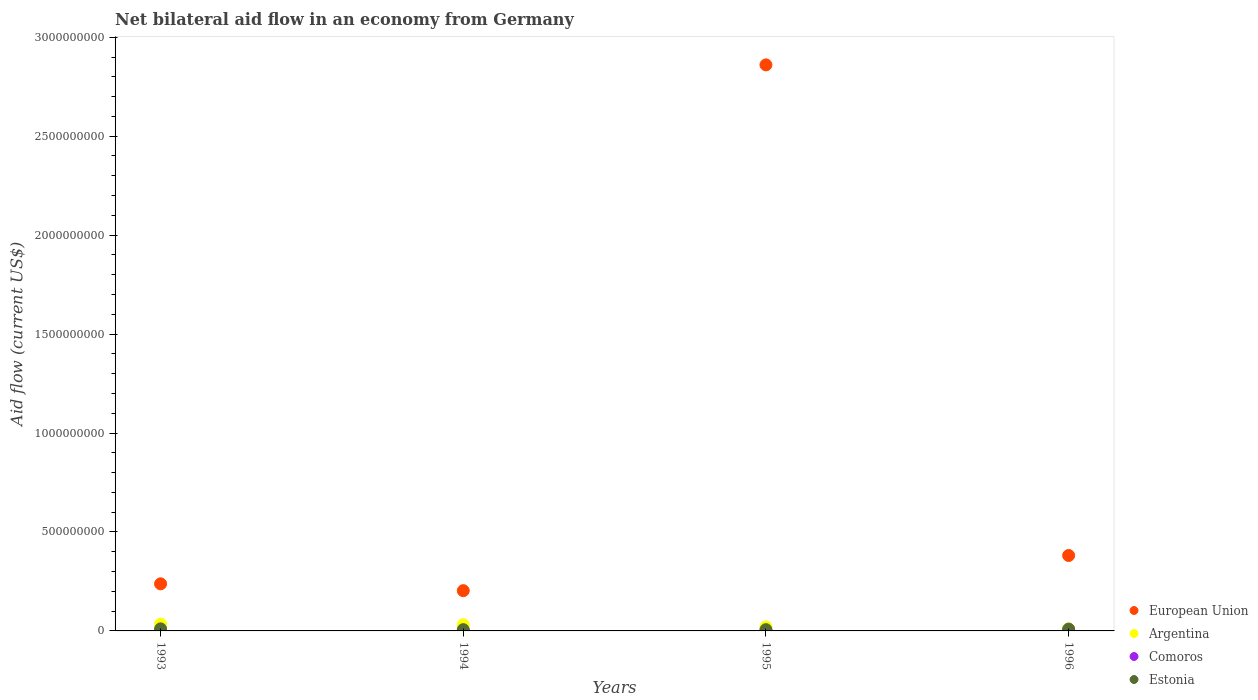What is the net bilateral aid flow in Estonia in 1995?
Provide a short and direct response. 6.40e+06. Across all years, what is the maximum net bilateral aid flow in European Union?
Provide a short and direct response. 2.86e+09. Across all years, what is the minimum net bilateral aid flow in European Union?
Provide a succinct answer. 2.03e+08. In which year was the net bilateral aid flow in Comoros minimum?
Your answer should be very brief. 1995. What is the total net bilateral aid flow in Argentina in the graph?
Keep it short and to the point. 9.65e+07. What is the difference between the net bilateral aid flow in Argentina in 1995 and that in 1996?
Keep it short and to the point. 1.02e+07. What is the difference between the net bilateral aid flow in Argentina in 1994 and the net bilateral aid flow in Estonia in 1996?
Keep it short and to the point. 2.22e+07. What is the average net bilateral aid flow in Estonia per year?
Provide a succinct answer. 8.15e+06. In the year 1994, what is the difference between the net bilateral aid flow in Argentina and net bilateral aid flow in Estonia?
Provide a short and direct response. 2.52e+07. What is the ratio of the net bilateral aid flow in Argentina in 1994 to that in 1995?
Provide a short and direct response. 1.54. Is the net bilateral aid flow in European Union in 1994 less than that in 1996?
Ensure brevity in your answer.  Yes. What is the difference between the highest and the second highest net bilateral aid flow in Estonia?
Make the answer very short. 1.11e+06. What is the difference between the highest and the lowest net bilateral aid flow in Estonia?
Your answer should be very brief. 4.08e+06. How many dotlines are there?
Your answer should be compact. 4. What is the difference between two consecutive major ticks on the Y-axis?
Give a very brief answer. 5.00e+08. Are the values on the major ticks of Y-axis written in scientific E-notation?
Offer a very short reply. No. Where does the legend appear in the graph?
Ensure brevity in your answer.  Bottom right. How many legend labels are there?
Offer a very short reply. 4. How are the legend labels stacked?
Offer a terse response. Vertical. What is the title of the graph?
Your answer should be very brief. Net bilateral aid flow in an economy from Germany. What is the label or title of the X-axis?
Ensure brevity in your answer.  Years. What is the label or title of the Y-axis?
Offer a terse response. Aid flow (current US$). What is the Aid flow (current US$) of European Union in 1993?
Offer a very short reply. 2.38e+08. What is the Aid flow (current US$) in Argentina in 1993?
Your answer should be compact. 3.42e+07. What is the Aid flow (current US$) of Comoros in 1993?
Keep it short and to the point. 1.64e+06. What is the Aid flow (current US$) of Estonia in 1993?
Offer a terse response. 1.05e+07. What is the Aid flow (current US$) of European Union in 1994?
Provide a short and direct response. 2.03e+08. What is the Aid flow (current US$) of Argentina in 1994?
Your answer should be very brief. 3.15e+07. What is the Aid flow (current US$) in Comoros in 1994?
Offer a terse response. 3.90e+05. What is the Aid flow (current US$) in Estonia in 1994?
Keep it short and to the point. 6.38e+06. What is the Aid flow (current US$) of European Union in 1995?
Provide a short and direct response. 2.86e+09. What is the Aid flow (current US$) of Argentina in 1995?
Provide a succinct answer. 2.05e+07. What is the Aid flow (current US$) of Estonia in 1995?
Your answer should be very brief. 6.40e+06. What is the Aid flow (current US$) of European Union in 1996?
Offer a very short reply. 3.81e+08. What is the Aid flow (current US$) in Argentina in 1996?
Offer a terse response. 1.03e+07. What is the Aid flow (current US$) in Comoros in 1996?
Your response must be concise. 9.50e+05. What is the Aid flow (current US$) in Estonia in 1996?
Offer a very short reply. 9.35e+06. Across all years, what is the maximum Aid flow (current US$) of European Union?
Offer a very short reply. 2.86e+09. Across all years, what is the maximum Aid flow (current US$) in Argentina?
Ensure brevity in your answer.  3.42e+07. Across all years, what is the maximum Aid flow (current US$) of Comoros?
Make the answer very short. 1.64e+06. Across all years, what is the maximum Aid flow (current US$) in Estonia?
Ensure brevity in your answer.  1.05e+07. Across all years, what is the minimum Aid flow (current US$) of European Union?
Give a very brief answer. 2.03e+08. Across all years, what is the minimum Aid flow (current US$) in Argentina?
Your response must be concise. 1.03e+07. Across all years, what is the minimum Aid flow (current US$) in Comoros?
Make the answer very short. 2.10e+05. Across all years, what is the minimum Aid flow (current US$) in Estonia?
Your answer should be compact. 6.38e+06. What is the total Aid flow (current US$) of European Union in the graph?
Offer a very short reply. 3.68e+09. What is the total Aid flow (current US$) of Argentina in the graph?
Keep it short and to the point. 9.65e+07. What is the total Aid flow (current US$) of Comoros in the graph?
Make the answer very short. 3.19e+06. What is the total Aid flow (current US$) of Estonia in the graph?
Your answer should be compact. 3.26e+07. What is the difference between the Aid flow (current US$) in European Union in 1993 and that in 1994?
Give a very brief answer. 3.46e+07. What is the difference between the Aid flow (current US$) in Argentina in 1993 and that in 1994?
Offer a terse response. 2.62e+06. What is the difference between the Aid flow (current US$) in Comoros in 1993 and that in 1994?
Offer a very short reply. 1.25e+06. What is the difference between the Aid flow (current US$) of Estonia in 1993 and that in 1994?
Ensure brevity in your answer.  4.08e+06. What is the difference between the Aid flow (current US$) in European Union in 1993 and that in 1995?
Make the answer very short. -2.62e+09. What is the difference between the Aid flow (current US$) of Argentina in 1993 and that in 1995?
Make the answer very short. 1.37e+07. What is the difference between the Aid flow (current US$) in Comoros in 1993 and that in 1995?
Offer a very short reply. 1.43e+06. What is the difference between the Aid flow (current US$) in Estonia in 1993 and that in 1995?
Provide a short and direct response. 4.06e+06. What is the difference between the Aid flow (current US$) in European Union in 1993 and that in 1996?
Provide a short and direct response. -1.43e+08. What is the difference between the Aid flow (current US$) in Argentina in 1993 and that in 1996?
Keep it short and to the point. 2.39e+07. What is the difference between the Aid flow (current US$) in Comoros in 1993 and that in 1996?
Provide a succinct answer. 6.90e+05. What is the difference between the Aid flow (current US$) in Estonia in 1993 and that in 1996?
Your answer should be very brief. 1.11e+06. What is the difference between the Aid flow (current US$) of European Union in 1994 and that in 1995?
Give a very brief answer. -2.66e+09. What is the difference between the Aid flow (current US$) of Argentina in 1994 and that in 1995?
Give a very brief answer. 1.11e+07. What is the difference between the Aid flow (current US$) of Estonia in 1994 and that in 1995?
Ensure brevity in your answer.  -2.00e+04. What is the difference between the Aid flow (current US$) in European Union in 1994 and that in 1996?
Provide a succinct answer. -1.78e+08. What is the difference between the Aid flow (current US$) in Argentina in 1994 and that in 1996?
Keep it short and to the point. 2.12e+07. What is the difference between the Aid flow (current US$) in Comoros in 1994 and that in 1996?
Your answer should be very brief. -5.60e+05. What is the difference between the Aid flow (current US$) in Estonia in 1994 and that in 1996?
Offer a terse response. -2.97e+06. What is the difference between the Aid flow (current US$) in European Union in 1995 and that in 1996?
Provide a succinct answer. 2.48e+09. What is the difference between the Aid flow (current US$) in Argentina in 1995 and that in 1996?
Provide a short and direct response. 1.02e+07. What is the difference between the Aid flow (current US$) in Comoros in 1995 and that in 1996?
Your answer should be compact. -7.40e+05. What is the difference between the Aid flow (current US$) of Estonia in 1995 and that in 1996?
Your response must be concise. -2.95e+06. What is the difference between the Aid flow (current US$) in European Union in 1993 and the Aid flow (current US$) in Argentina in 1994?
Your answer should be very brief. 2.06e+08. What is the difference between the Aid flow (current US$) in European Union in 1993 and the Aid flow (current US$) in Comoros in 1994?
Your response must be concise. 2.38e+08. What is the difference between the Aid flow (current US$) of European Union in 1993 and the Aid flow (current US$) of Estonia in 1994?
Your answer should be compact. 2.32e+08. What is the difference between the Aid flow (current US$) of Argentina in 1993 and the Aid flow (current US$) of Comoros in 1994?
Offer a terse response. 3.38e+07. What is the difference between the Aid flow (current US$) in Argentina in 1993 and the Aid flow (current US$) in Estonia in 1994?
Provide a short and direct response. 2.78e+07. What is the difference between the Aid flow (current US$) in Comoros in 1993 and the Aid flow (current US$) in Estonia in 1994?
Provide a short and direct response. -4.74e+06. What is the difference between the Aid flow (current US$) in European Union in 1993 and the Aid flow (current US$) in Argentina in 1995?
Make the answer very short. 2.18e+08. What is the difference between the Aid flow (current US$) of European Union in 1993 and the Aid flow (current US$) of Comoros in 1995?
Make the answer very short. 2.38e+08. What is the difference between the Aid flow (current US$) of European Union in 1993 and the Aid flow (current US$) of Estonia in 1995?
Your answer should be very brief. 2.32e+08. What is the difference between the Aid flow (current US$) in Argentina in 1993 and the Aid flow (current US$) in Comoros in 1995?
Your response must be concise. 3.40e+07. What is the difference between the Aid flow (current US$) in Argentina in 1993 and the Aid flow (current US$) in Estonia in 1995?
Your response must be concise. 2.78e+07. What is the difference between the Aid flow (current US$) in Comoros in 1993 and the Aid flow (current US$) in Estonia in 1995?
Make the answer very short. -4.76e+06. What is the difference between the Aid flow (current US$) in European Union in 1993 and the Aid flow (current US$) in Argentina in 1996?
Your response must be concise. 2.28e+08. What is the difference between the Aid flow (current US$) in European Union in 1993 and the Aid flow (current US$) in Comoros in 1996?
Make the answer very short. 2.37e+08. What is the difference between the Aid flow (current US$) of European Union in 1993 and the Aid flow (current US$) of Estonia in 1996?
Provide a short and direct response. 2.29e+08. What is the difference between the Aid flow (current US$) of Argentina in 1993 and the Aid flow (current US$) of Comoros in 1996?
Give a very brief answer. 3.32e+07. What is the difference between the Aid flow (current US$) in Argentina in 1993 and the Aid flow (current US$) in Estonia in 1996?
Your answer should be very brief. 2.48e+07. What is the difference between the Aid flow (current US$) in Comoros in 1993 and the Aid flow (current US$) in Estonia in 1996?
Ensure brevity in your answer.  -7.71e+06. What is the difference between the Aid flow (current US$) of European Union in 1994 and the Aid flow (current US$) of Argentina in 1995?
Your response must be concise. 1.83e+08. What is the difference between the Aid flow (current US$) of European Union in 1994 and the Aid flow (current US$) of Comoros in 1995?
Ensure brevity in your answer.  2.03e+08. What is the difference between the Aid flow (current US$) in European Union in 1994 and the Aid flow (current US$) in Estonia in 1995?
Offer a terse response. 1.97e+08. What is the difference between the Aid flow (current US$) in Argentina in 1994 and the Aid flow (current US$) in Comoros in 1995?
Offer a terse response. 3.13e+07. What is the difference between the Aid flow (current US$) of Argentina in 1994 and the Aid flow (current US$) of Estonia in 1995?
Your response must be concise. 2.51e+07. What is the difference between the Aid flow (current US$) of Comoros in 1994 and the Aid flow (current US$) of Estonia in 1995?
Make the answer very short. -6.01e+06. What is the difference between the Aid flow (current US$) of European Union in 1994 and the Aid flow (current US$) of Argentina in 1996?
Provide a succinct answer. 1.93e+08. What is the difference between the Aid flow (current US$) of European Union in 1994 and the Aid flow (current US$) of Comoros in 1996?
Provide a succinct answer. 2.02e+08. What is the difference between the Aid flow (current US$) in European Union in 1994 and the Aid flow (current US$) in Estonia in 1996?
Give a very brief answer. 1.94e+08. What is the difference between the Aid flow (current US$) of Argentina in 1994 and the Aid flow (current US$) of Comoros in 1996?
Give a very brief answer. 3.06e+07. What is the difference between the Aid flow (current US$) of Argentina in 1994 and the Aid flow (current US$) of Estonia in 1996?
Keep it short and to the point. 2.22e+07. What is the difference between the Aid flow (current US$) in Comoros in 1994 and the Aid flow (current US$) in Estonia in 1996?
Ensure brevity in your answer.  -8.96e+06. What is the difference between the Aid flow (current US$) in European Union in 1995 and the Aid flow (current US$) in Argentina in 1996?
Your answer should be compact. 2.85e+09. What is the difference between the Aid flow (current US$) in European Union in 1995 and the Aid flow (current US$) in Comoros in 1996?
Your response must be concise. 2.86e+09. What is the difference between the Aid flow (current US$) of European Union in 1995 and the Aid flow (current US$) of Estonia in 1996?
Give a very brief answer. 2.85e+09. What is the difference between the Aid flow (current US$) of Argentina in 1995 and the Aid flow (current US$) of Comoros in 1996?
Give a very brief answer. 1.95e+07. What is the difference between the Aid flow (current US$) in Argentina in 1995 and the Aid flow (current US$) in Estonia in 1996?
Make the answer very short. 1.11e+07. What is the difference between the Aid flow (current US$) in Comoros in 1995 and the Aid flow (current US$) in Estonia in 1996?
Offer a very short reply. -9.14e+06. What is the average Aid flow (current US$) in European Union per year?
Provide a short and direct response. 9.21e+08. What is the average Aid flow (current US$) of Argentina per year?
Provide a short and direct response. 2.41e+07. What is the average Aid flow (current US$) of Comoros per year?
Your response must be concise. 7.98e+05. What is the average Aid flow (current US$) in Estonia per year?
Provide a succinct answer. 8.15e+06. In the year 1993, what is the difference between the Aid flow (current US$) in European Union and Aid flow (current US$) in Argentina?
Your response must be concise. 2.04e+08. In the year 1993, what is the difference between the Aid flow (current US$) in European Union and Aid flow (current US$) in Comoros?
Your answer should be very brief. 2.36e+08. In the year 1993, what is the difference between the Aid flow (current US$) of European Union and Aid flow (current US$) of Estonia?
Offer a terse response. 2.28e+08. In the year 1993, what is the difference between the Aid flow (current US$) of Argentina and Aid flow (current US$) of Comoros?
Give a very brief answer. 3.25e+07. In the year 1993, what is the difference between the Aid flow (current US$) of Argentina and Aid flow (current US$) of Estonia?
Your answer should be very brief. 2.37e+07. In the year 1993, what is the difference between the Aid flow (current US$) of Comoros and Aid flow (current US$) of Estonia?
Provide a succinct answer. -8.82e+06. In the year 1994, what is the difference between the Aid flow (current US$) in European Union and Aid flow (current US$) in Argentina?
Offer a terse response. 1.72e+08. In the year 1994, what is the difference between the Aid flow (current US$) of European Union and Aid flow (current US$) of Comoros?
Offer a terse response. 2.03e+08. In the year 1994, what is the difference between the Aid flow (current US$) in European Union and Aid flow (current US$) in Estonia?
Keep it short and to the point. 1.97e+08. In the year 1994, what is the difference between the Aid flow (current US$) in Argentina and Aid flow (current US$) in Comoros?
Offer a very short reply. 3.12e+07. In the year 1994, what is the difference between the Aid flow (current US$) in Argentina and Aid flow (current US$) in Estonia?
Keep it short and to the point. 2.52e+07. In the year 1994, what is the difference between the Aid flow (current US$) of Comoros and Aid flow (current US$) of Estonia?
Your response must be concise. -5.99e+06. In the year 1995, what is the difference between the Aid flow (current US$) in European Union and Aid flow (current US$) in Argentina?
Offer a terse response. 2.84e+09. In the year 1995, what is the difference between the Aid flow (current US$) of European Union and Aid flow (current US$) of Comoros?
Offer a very short reply. 2.86e+09. In the year 1995, what is the difference between the Aid flow (current US$) of European Union and Aid flow (current US$) of Estonia?
Give a very brief answer. 2.85e+09. In the year 1995, what is the difference between the Aid flow (current US$) of Argentina and Aid flow (current US$) of Comoros?
Your response must be concise. 2.03e+07. In the year 1995, what is the difference between the Aid flow (current US$) of Argentina and Aid flow (current US$) of Estonia?
Provide a short and direct response. 1.41e+07. In the year 1995, what is the difference between the Aid flow (current US$) of Comoros and Aid flow (current US$) of Estonia?
Offer a terse response. -6.19e+06. In the year 1996, what is the difference between the Aid flow (current US$) in European Union and Aid flow (current US$) in Argentina?
Provide a succinct answer. 3.71e+08. In the year 1996, what is the difference between the Aid flow (current US$) of European Union and Aid flow (current US$) of Comoros?
Provide a succinct answer. 3.80e+08. In the year 1996, what is the difference between the Aid flow (current US$) in European Union and Aid flow (current US$) in Estonia?
Provide a succinct answer. 3.72e+08. In the year 1996, what is the difference between the Aid flow (current US$) of Argentina and Aid flow (current US$) of Comoros?
Give a very brief answer. 9.35e+06. In the year 1996, what is the difference between the Aid flow (current US$) of Argentina and Aid flow (current US$) of Estonia?
Ensure brevity in your answer.  9.50e+05. In the year 1996, what is the difference between the Aid flow (current US$) in Comoros and Aid flow (current US$) in Estonia?
Ensure brevity in your answer.  -8.40e+06. What is the ratio of the Aid flow (current US$) in European Union in 1993 to that in 1994?
Give a very brief answer. 1.17. What is the ratio of the Aid flow (current US$) in Argentina in 1993 to that in 1994?
Ensure brevity in your answer.  1.08. What is the ratio of the Aid flow (current US$) of Comoros in 1993 to that in 1994?
Make the answer very short. 4.21. What is the ratio of the Aid flow (current US$) in Estonia in 1993 to that in 1994?
Offer a very short reply. 1.64. What is the ratio of the Aid flow (current US$) of European Union in 1993 to that in 1995?
Keep it short and to the point. 0.08. What is the ratio of the Aid flow (current US$) of Argentina in 1993 to that in 1995?
Provide a short and direct response. 1.67. What is the ratio of the Aid flow (current US$) in Comoros in 1993 to that in 1995?
Your response must be concise. 7.81. What is the ratio of the Aid flow (current US$) of Estonia in 1993 to that in 1995?
Your response must be concise. 1.63. What is the ratio of the Aid flow (current US$) in European Union in 1993 to that in 1996?
Offer a terse response. 0.62. What is the ratio of the Aid flow (current US$) of Argentina in 1993 to that in 1996?
Offer a very short reply. 3.32. What is the ratio of the Aid flow (current US$) in Comoros in 1993 to that in 1996?
Provide a succinct answer. 1.73. What is the ratio of the Aid flow (current US$) of Estonia in 1993 to that in 1996?
Provide a succinct answer. 1.12. What is the ratio of the Aid flow (current US$) of European Union in 1994 to that in 1995?
Give a very brief answer. 0.07. What is the ratio of the Aid flow (current US$) of Argentina in 1994 to that in 1995?
Provide a succinct answer. 1.54. What is the ratio of the Aid flow (current US$) of Comoros in 1994 to that in 1995?
Your answer should be very brief. 1.86. What is the ratio of the Aid flow (current US$) of European Union in 1994 to that in 1996?
Ensure brevity in your answer.  0.53. What is the ratio of the Aid flow (current US$) in Argentina in 1994 to that in 1996?
Your answer should be compact. 3.06. What is the ratio of the Aid flow (current US$) of Comoros in 1994 to that in 1996?
Offer a terse response. 0.41. What is the ratio of the Aid flow (current US$) in Estonia in 1994 to that in 1996?
Offer a very short reply. 0.68. What is the ratio of the Aid flow (current US$) in European Union in 1995 to that in 1996?
Offer a terse response. 7.5. What is the ratio of the Aid flow (current US$) of Argentina in 1995 to that in 1996?
Your answer should be very brief. 1.99. What is the ratio of the Aid flow (current US$) of Comoros in 1995 to that in 1996?
Your response must be concise. 0.22. What is the ratio of the Aid flow (current US$) in Estonia in 1995 to that in 1996?
Provide a short and direct response. 0.68. What is the difference between the highest and the second highest Aid flow (current US$) of European Union?
Provide a succinct answer. 2.48e+09. What is the difference between the highest and the second highest Aid flow (current US$) of Argentina?
Keep it short and to the point. 2.62e+06. What is the difference between the highest and the second highest Aid flow (current US$) of Comoros?
Provide a succinct answer. 6.90e+05. What is the difference between the highest and the second highest Aid flow (current US$) in Estonia?
Your answer should be very brief. 1.11e+06. What is the difference between the highest and the lowest Aid flow (current US$) in European Union?
Provide a succinct answer. 2.66e+09. What is the difference between the highest and the lowest Aid flow (current US$) in Argentina?
Give a very brief answer. 2.39e+07. What is the difference between the highest and the lowest Aid flow (current US$) of Comoros?
Provide a succinct answer. 1.43e+06. What is the difference between the highest and the lowest Aid flow (current US$) of Estonia?
Offer a terse response. 4.08e+06. 